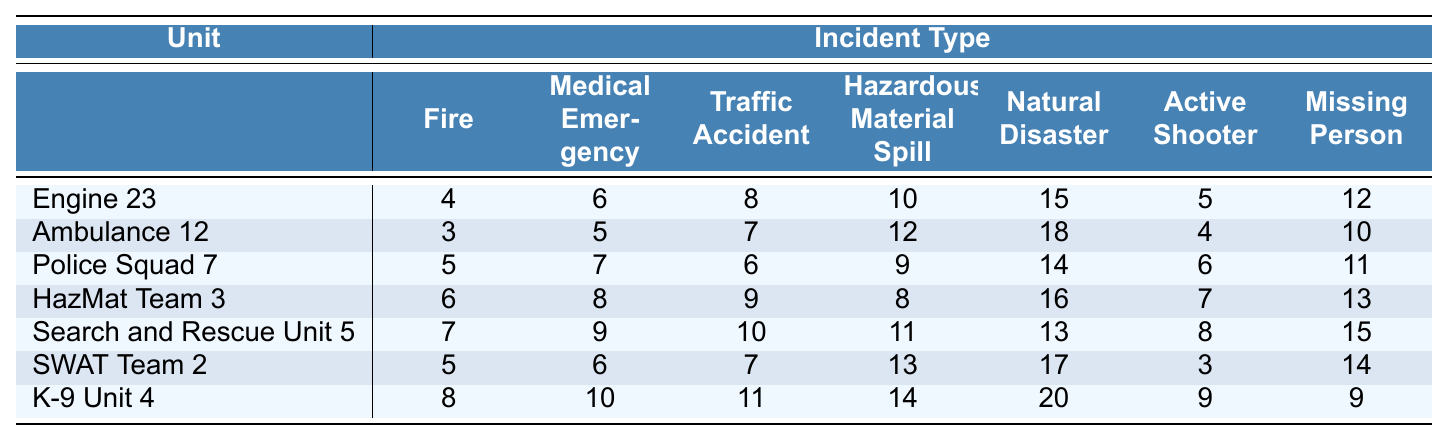What is the response time for Engine 23 to a Fire incident? According to the table, Engine 23 has a response time of 4 minutes for a Fire incident.
Answer: 4 minutes Which unit has the quickest response time for a Medical Emergency? The table shows that Ambulance 12 has the quickest response time of 5 minutes for a Medical Emergency.
Answer: Ambulance 12 What is the average response time for the Traffic Accident incident across all units? The response times for Traffic Accident are: 8, 7, 6, 9, 10, 7, 11. The sum of these times is 58. There are 7 units, so the average is 58/7 = 8.29 minutes.
Answer: 8.29 minutes What is the response time for HazMat Team 3 when responding to a Natural Disaster? HazMat Team 3 has a response time of 16 minutes for a Natural Disaster incident as seen in the table.
Answer: 16 minutes Which incident has the longest response time by K-9 Unit 4? K-9 Unit 4's response times for different incidents are 8 (Fire), 10 (Medical Emergency), 11 (Traffic Accident), 14 (Hazardous Material Spill), 20 (Natural Disaster), 9 (Active Shooter), and 9 (Missing Person). The longest time is 20 minutes for a Natural Disaster.
Answer: Natural Disaster Is the response time for an Active Shooter incident higher than 10 minutes for all units? The response times for Active Shooter are: 5, 4, 6, 7, 8, 3, 9. The maximum is 9 minutes, which is not higher than 10 minutes. Thus, it is false that all units have higher response times than 10 minutes.
Answer: No Which unit takes longer for a Missing Person incident, Engine 23 or Police Squad 7? Engine 23's response for Missing Person is 12 minutes, while Police Squad 7's is 11 minutes. Therefore, Engine 23 takes longer.
Answer: Engine 23 What is the difference in response time between the fastest and slowest unit for a Fire incident? The fastest response time for a Fire incident is 3 minutes (Ambulance 12) and the slowest is 8 minutes (Police Squad 7). The difference is 8 - 3 = 5 minutes.
Answer: 5 minutes Which incident requires the longest response time by any unit? The highest response time in the table is 20 minutes for a Natural Disaster by K-9 Unit 4.
Answer: Natural Disaster What is the total response time for all units responding to a Traffic Accident incident? The response times for Traffic Accident are: 8, 7, 6, 9, 10, 7, 11. Adding these gives 58 minutes as the total response time for all units.
Answer: 58 minutes 